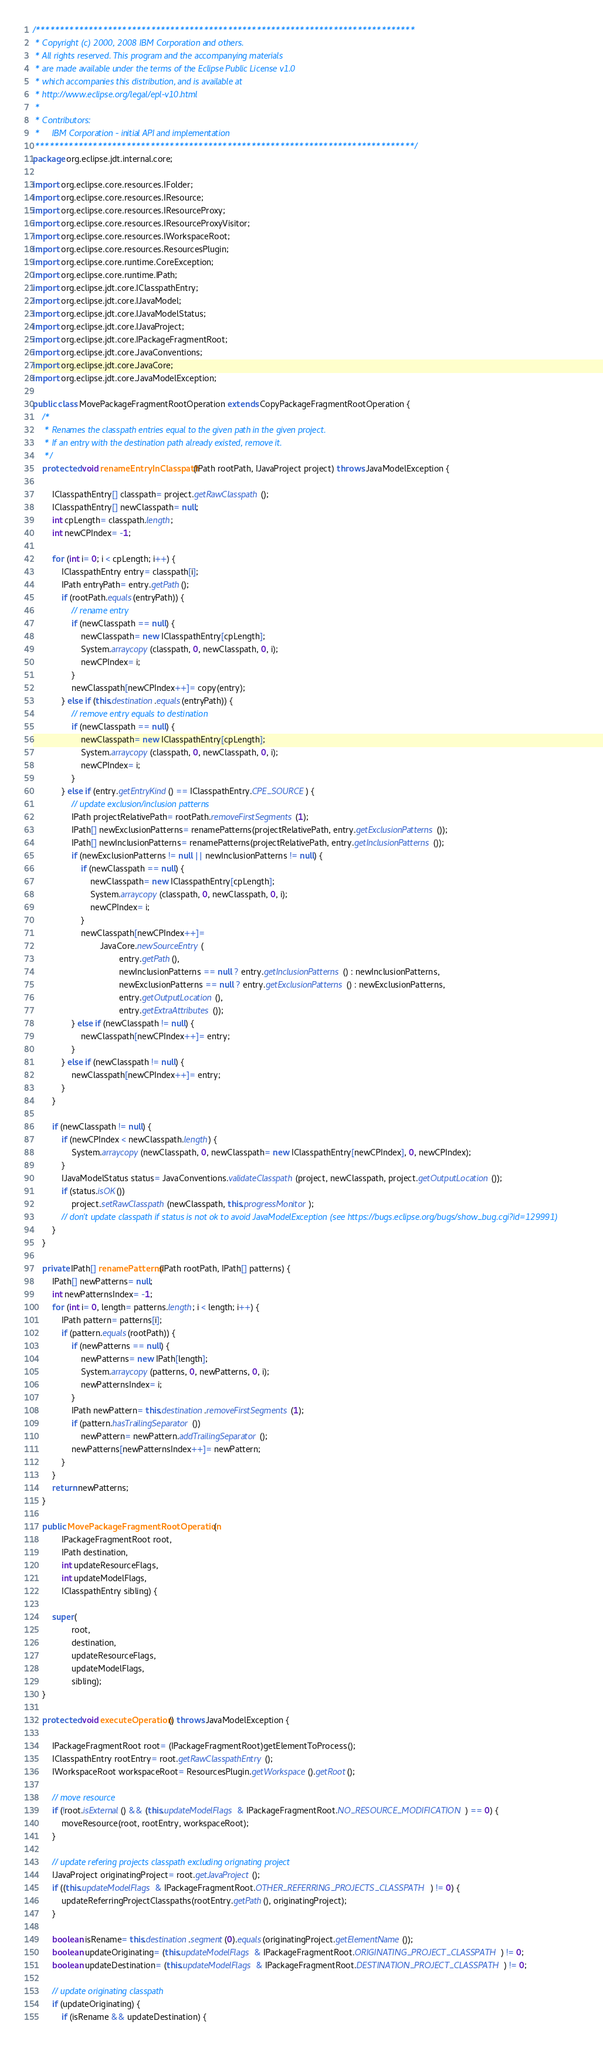Convert code to text. <code><loc_0><loc_0><loc_500><loc_500><_Java_>/*******************************************************************************
 * Copyright (c) 2000, 2008 IBM Corporation and others.
 * All rights reserved. This program and the accompanying materials
 * are made available under the terms of the Eclipse Public License v1.0
 * which accompanies this distribution, and is available at
 * http://www.eclipse.org/legal/epl-v10.html
 *
 * Contributors:
 *     IBM Corporation - initial API and implementation
 *******************************************************************************/
package org.eclipse.jdt.internal.core;

import org.eclipse.core.resources.IFolder;
import org.eclipse.core.resources.IResource;
import org.eclipse.core.resources.IResourceProxy;
import org.eclipse.core.resources.IResourceProxyVisitor;
import org.eclipse.core.resources.IWorkspaceRoot;
import org.eclipse.core.resources.ResourcesPlugin;
import org.eclipse.core.runtime.CoreException;
import org.eclipse.core.runtime.IPath;
import org.eclipse.jdt.core.IClasspathEntry;
import org.eclipse.jdt.core.IJavaModel;
import org.eclipse.jdt.core.IJavaModelStatus;
import org.eclipse.jdt.core.IJavaProject;
import org.eclipse.jdt.core.IPackageFragmentRoot;
import org.eclipse.jdt.core.JavaConventions;
import org.eclipse.jdt.core.JavaCore;
import org.eclipse.jdt.core.JavaModelException;

public class MovePackageFragmentRootOperation extends CopyPackageFragmentRootOperation {
	/*
	 * Renames the classpath entries equal to the given path in the given project.
	 * If an entry with the destination path already existed, remove it.
	 */
	protected void renameEntryInClasspath(IPath rootPath, IJavaProject project) throws JavaModelException {

		IClasspathEntry[] classpath= project.getRawClasspath();
		IClasspathEntry[] newClasspath= null;
		int cpLength= classpath.length;
		int newCPIndex= -1;

		for (int i= 0; i < cpLength; i++) {
			IClasspathEntry entry= classpath[i];
			IPath entryPath= entry.getPath();
			if (rootPath.equals(entryPath)) {
				// rename entry
				if (newClasspath == null) {
					newClasspath= new IClasspathEntry[cpLength];
					System.arraycopy(classpath, 0, newClasspath, 0, i);
					newCPIndex= i;
				}
				newClasspath[newCPIndex++]= copy(entry);
			} else if (this.destination.equals(entryPath)) {
				// remove entry equals to destination
				if (newClasspath == null) {
					newClasspath= new IClasspathEntry[cpLength];
					System.arraycopy(classpath, 0, newClasspath, 0, i);
					newCPIndex= i;
				}
			} else if (entry.getEntryKind() == IClasspathEntry.CPE_SOURCE) {
				// update exclusion/inclusion patterns
				IPath projectRelativePath= rootPath.removeFirstSegments(1);
				IPath[] newExclusionPatterns= renamePatterns(projectRelativePath, entry.getExclusionPatterns());
				IPath[] newInclusionPatterns= renamePatterns(projectRelativePath, entry.getInclusionPatterns());
				if (newExclusionPatterns != null || newInclusionPatterns != null) {
					if (newClasspath == null) {
						newClasspath= new IClasspathEntry[cpLength];
						System.arraycopy(classpath, 0, newClasspath, 0, i);
						newCPIndex= i;
					}
					newClasspath[newCPIndex++]=
							JavaCore.newSourceEntry(
									entry.getPath(),
									newInclusionPatterns == null ? entry.getInclusionPatterns() : newInclusionPatterns,
									newExclusionPatterns == null ? entry.getExclusionPatterns() : newExclusionPatterns,
									entry.getOutputLocation(),
									entry.getExtraAttributes());
				} else if (newClasspath != null) {
					newClasspath[newCPIndex++]= entry;
				}
			} else if (newClasspath != null) {
				newClasspath[newCPIndex++]= entry;
			}
		}

		if (newClasspath != null) {
			if (newCPIndex < newClasspath.length) {
				System.arraycopy(newClasspath, 0, newClasspath= new IClasspathEntry[newCPIndex], 0, newCPIndex);
			}
			IJavaModelStatus status= JavaConventions.validateClasspath(project, newClasspath, project.getOutputLocation());
			if (status.isOK())
				project.setRawClasspath(newClasspath, this.progressMonitor);
			// don't update classpath if status is not ok to avoid JavaModelException (see https://bugs.eclipse.org/bugs/show_bug.cgi?id=129991)
		}
	}

	private IPath[] renamePatterns(IPath rootPath, IPath[] patterns) {
		IPath[] newPatterns= null;
		int newPatternsIndex= -1;
		for (int i= 0, length= patterns.length; i < length; i++) {
			IPath pattern= patterns[i];
			if (pattern.equals(rootPath)) {
				if (newPatterns == null) {
					newPatterns= new IPath[length];
					System.arraycopy(patterns, 0, newPatterns, 0, i);
					newPatternsIndex= i;
				}
				IPath newPattern= this.destination.removeFirstSegments(1);
				if (pattern.hasTrailingSeparator())
					newPattern= newPattern.addTrailingSeparator();
				newPatterns[newPatternsIndex++]= newPattern;
			}
		}
		return newPatterns;
	}

	public MovePackageFragmentRootOperation(
			IPackageFragmentRoot root,
			IPath destination,
			int updateResourceFlags,
			int updateModelFlags,
			IClasspathEntry sibling) {

		super(
				root,
				destination,
				updateResourceFlags,
				updateModelFlags,
				sibling);
	}

	protected void executeOperation() throws JavaModelException {

		IPackageFragmentRoot root= (IPackageFragmentRoot)getElementToProcess();
		IClasspathEntry rootEntry= root.getRawClasspathEntry();
		IWorkspaceRoot workspaceRoot= ResourcesPlugin.getWorkspace().getRoot();

		// move resource
		if (!root.isExternal() && (this.updateModelFlags & IPackageFragmentRoot.NO_RESOURCE_MODIFICATION) == 0) {
			moveResource(root, rootEntry, workspaceRoot);
		}

		// update refering projects classpath excluding orignating project
		IJavaProject originatingProject= root.getJavaProject();
		if ((this.updateModelFlags & IPackageFragmentRoot.OTHER_REFERRING_PROJECTS_CLASSPATH) != 0) {
			updateReferringProjectClasspaths(rootEntry.getPath(), originatingProject);
		}

		boolean isRename= this.destination.segment(0).equals(originatingProject.getElementName());
		boolean updateOriginating= (this.updateModelFlags & IPackageFragmentRoot.ORIGINATING_PROJECT_CLASSPATH) != 0;
		boolean updateDestination= (this.updateModelFlags & IPackageFragmentRoot.DESTINATION_PROJECT_CLASSPATH) != 0;

		// update originating classpath
		if (updateOriginating) {
			if (isRename && updateDestination) {</code> 